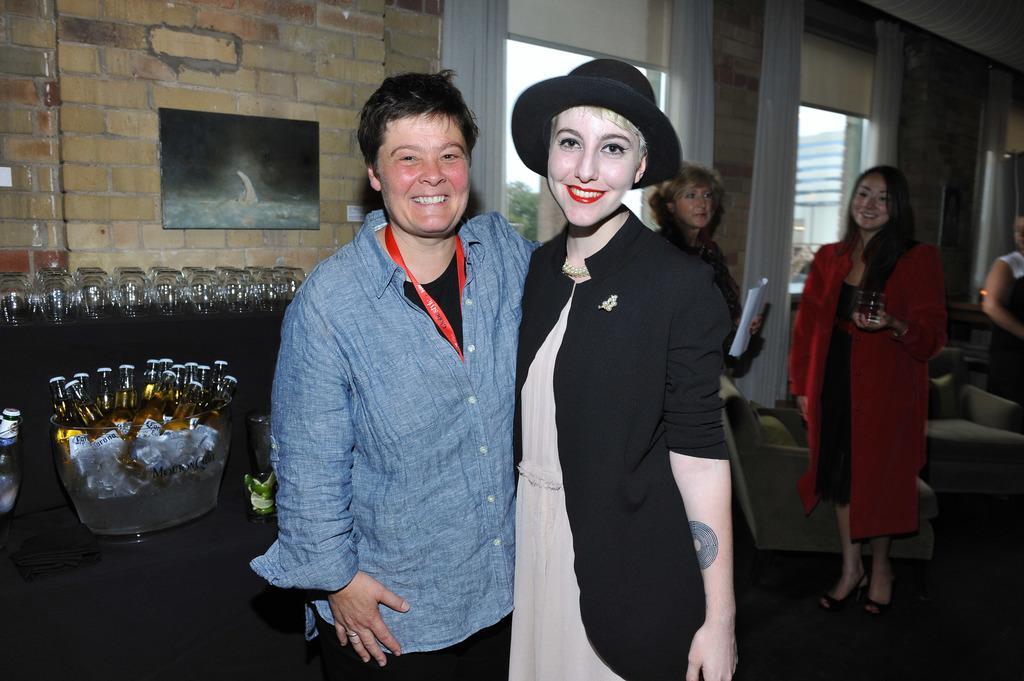How would you summarize this image in a sentence or two? In this image we can see the people standing on the floor and holding a glass and paper. And at the back we can see a table with a cloth, on the table there are glass, bowl and bottles. In the background, we can see the wall with windows, curtain and board. 